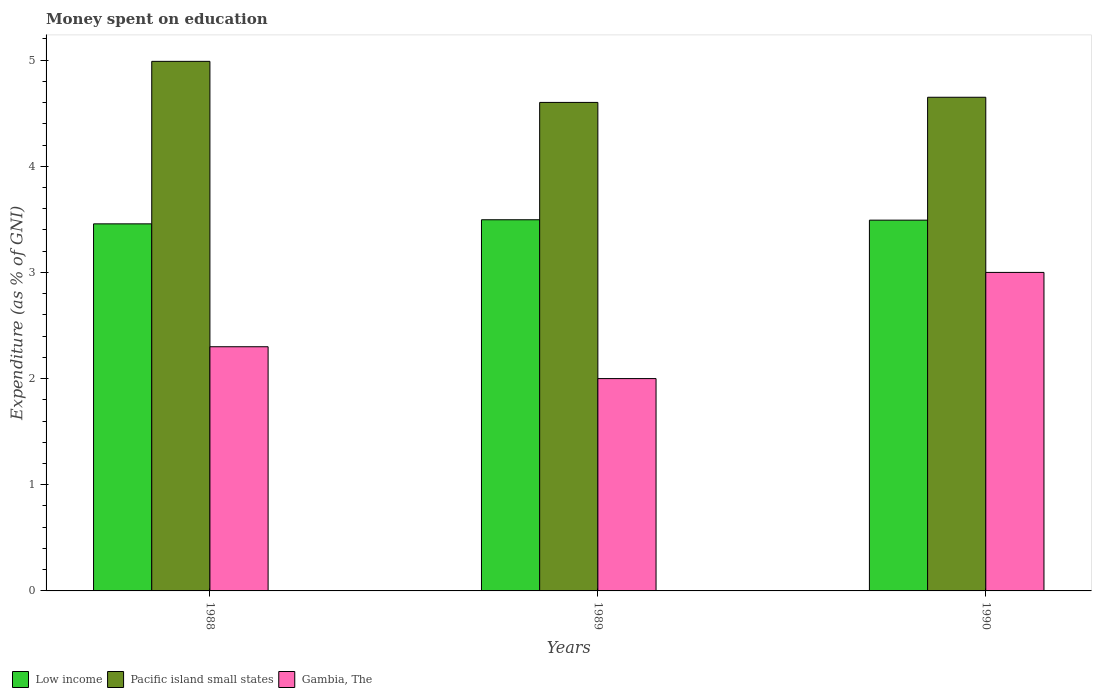How many different coloured bars are there?
Ensure brevity in your answer.  3. How many groups of bars are there?
Make the answer very short. 3. Are the number of bars per tick equal to the number of legend labels?
Provide a short and direct response. Yes. Are the number of bars on each tick of the X-axis equal?
Offer a terse response. Yes. How many bars are there on the 3rd tick from the right?
Provide a succinct answer. 3. What is the label of the 2nd group of bars from the left?
Give a very brief answer. 1989. In how many cases, is the number of bars for a given year not equal to the number of legend labels?
Keep it short and to the point. 0. What is the amount of money spent on education in Low income in 1989?
Your answer should be very brief. 3.5. Across all years, what is the maximum amount of money spent on education in Low income?
Your answer should be very brief. 3.5. Across all years, what is the minimum amount of money spent on education in Pacific island small states?
Ensure brevity in your answer.  4.6. In which year was the amount of money spent on education in Low income minimum?
Offer a very short reply. 1988. What is the total amount of money spent on education in Gambia, The in the graph?
Give a very brief answer. 7.3. What is the difference between the amount of money spent on education in Pacific island small states in 1988 and that in 1990?
Ensure brevity in your answer.  0.34. What is the difference between the amount of money spent on education in Low income in 1988 and the amount of money spent on education in Pacific island small states in 1990?
Offer a terse response. -1.19. What is the average amount of money spent on education in Low income per year?
Keep it short and to the point. 3.48. In the year 1988, what is the difference between the amount of money spent on education in Low income and amount of money spent on education in Gambia, The?
Offer a terse response. 1.16. In how many years, is the amount of money spent on education in Gambia, The greater than 0.4 %?
Your response must be concise. 3. What is the ratio of the amount of money spent on education in Gambia, The in 1988 to that in 1989?
Provide a short and direct response. 1.15. What is the difference between the highest and the second highest amount of money spent on education in Gambia, The?
Offer a terse response. 0.7. What is the difference between the highest and the lowest amount of money spent on education in Low income?
Keep it short and to the point. 0.04. What does the 3rd bar from the left in 1988 represents?
Your answer should be compact. Gambia, The. What does the 2nd bar from the right in 1989 represents?
Your answer should be very brief. Pacific island small states. How many years are there in the graph?
Provide a succinct answer. 3. How many legend labels are there?
Provide a short and direct response. 3. How are the legend labels stacked?
Offer a very short reply. Horizontal. What is the title of the graph?
Provide a short and direct response. Money spent on education. What is the label or title of the Y-axis?
Your answer should be very brief. Expenditure (as % of GNI). What is the Expenditure (as % of GNI) of Low income in 1988?
Keep it short and to the point. 3.46. What is the Expenditure (as % of GNI) of Pacific island small states in 1988?
Offer a terse response. 4.99. What is the Expenditure (as % of GNI) in Gambia, The in 1988?
Provide a short and direct response. 2.3. What is the Expenditure (as % of GNI) in Low income in 1989?
Provide a succinct answer. 3.5. What is the Expenditure (as % of GNI) in Pacific island small states in 1989?
Provide a succinct answer. 4.6. What is the Expenditure (as % of GNI) of Low income in 1990?
Make the answer very short. 3.49. What is the Expenditure (as % of GNI) in Pacific island small states in 1990?
Provide a short and direct response. 4.65. What is the Expenditure (as % of GNI) of Gambia, The in 1990?
Offer a very short reply. 3. Across all years, what is the maximum Expenditure (as % of GNI) in Low income?
Offer a very short reply. 3.5. Across all years, what is the maximum Expenditure (as % of GNI) in Pacific island small states?
Offer a very short reply. 4.99. Across all years, what is the maximum Expenditure (as % of GNI) in Gambia, The?
Offer a terse response. 3. Across all years, what is the minimum Expenditure (as % of GNI) of Low income?
Offer a terse response. 3.46. Across all years, what is the minimum Expenditure (as % of GNI) of Pacific island small states?
Offer a very short reply. 4.6. Across all years, what is the minimum Expenditure (as % of GNI) in Gambia, The?
Your response must be concise. 2. What is the total Expenditure (as % of GNI) of Low income in the graph?
Your answer should be compact. 10.45. What is the total Expenditure (as % of GNI) in Pacific island small states in the graph?
Ensure brevity in your answer.  14.24. What is the difference between the Expenditure (as % of GNI) of Low income in 1988 and that in 1989?
Provide a short and direct response. -0.04. What is the difference between the Expenditure (as % of GNI) of Pacific island small states in 1988 and that in 1989?
Give a very brief answer. 0.39. What is the difference between the Expenditure (as % of GNI) of Gambia, The in 1988 and that in 1989?
Provide a succinct answer. 0.3. What is the difference between the Expenditure (as % of GNI) in Low income in 1988 and that in 1990?
Ensure brevity in your answer.  -0.03. What is the difference between the Expenditure (as % of GNI) of Pacific island small states in 1988 and that in 1990?
Offer a very short reply. 0.34. What is the difference between the Expenditure (as % of GNI) of Gambia, The in 1988 and that in 1990?
Ensure brevity in your answer.  -0.7. What is the difference between the Expenditure (as % of GNI) of Low income in 1989 and that in 1990?
Make the answer very short. 0. What is the difference between the Expenditure (as % of GNI) in Pacific island small states in 1989 and that in 1990?
Keep it short and to the point. -0.05. What is the difference between the Expenditure (as % of GNI) in Gambia, The in 1989 and that in 1990?
Provide a succinct answer. -1. What is the difference between the Expenditure (as % of GNI) in Low income in 1988 and the Expenditure (as % of GNI) in Pacific island small states in 1989?
Give a very brief answer. -1.14. What is the difference between the Expenditure (as % of GNI) in Low income in 1988 and the Expenditure (as % of GNI) in Gambia, The in 1989?
Ensure brevity in your answer.  1.46. What is the difference between the Expenditure (as % of GNI) in Pacific island small states in 1988 and the Expenditure (as % of GNI) in Gambia, The in 1989?
Make the answer very short. 2.99. What is the difference between the Expenditure (as % of GNI) of Low income in 1988 and the Expenditure (as % of GNI) of Pacific island small states in 1990?
Keep it short and to the point. -1.19. What is the difference between the Expenditure (as % of GNI) in Low income in 1988 and the Expenditure (as % of GNI) in Gambia, The in 1990?
Provide a short and direct response. 0.46. What is the difference between the Expenditure (as % of GNI) of Pacific island small states in 1988 and the Expenditure (as % of GNI) of Gambia, The in 1990?
Your answer should be compact. 1.99. What is the difference between the Expenditure (as % of GNI) in Low income in 1989 and the Expenditure (as % of GNI) in Pacific island small states in 1990?
Offer a terse response. -1.15. What is the difference between the Expenditure (as % of GNI) of Low income in 1989 and the Expenditure (as % of GNI) of Gambia, The in 1990?
Offer a terse response. 0.5. What is the difference between the Expenditure (as % of GNI) in Pacific island small states in 1989 and the Expenditure (as % of GNI) in Gambia, The in 1990?
Your answer should be very brief. 1.6. What is the average Expenditure (as % of GNI) in Low income per year?
Offer a very short reply. 3.48. What is the average Expenditure (as % of GNI) of Pacific island small states per year?
Ensure brevity in your answer.  4.75. What is the average Expenditure (as % of GNI) of Gambia, The per year?
Ensure brevity in your answer.  2.43. In the year 1988, what is the difference between the Expenditure (as % of GNI) in Low income and Expenditure (as % of GNI) in Pacific island small states?
Your answer should be compact. -1.53. In the year 1988, what is the difference between the Expenditure (as % of GNI) of Low income and Expenditure (as % of GNI) of Gambia, The?
Provide a short and direct response. 1.16. In the year 1988, what is the difference between the Expenditure (as % of GNI) in Pacific island small states and Expenditure (as % of GNI) in Gambia, The?
Your response must be concise. 2.69. In the year 1989, what is the difference between the Expenditure (as % of GNI) in Low income and Expenditure (as % of GNI) in Pacific island small states?
Your answer should be compact. -1.11. In the year 1989, what is the difference between the Expenditure (as % of GNI) in Low income and Expenditure (as % of GNI) in Gambia, The?
Your answer should be very brief. 1.5. In the year 1989, what is the difference between the Expenditure (as % of GNI) of Pacific island small states and Expenditure (as % of GNI) of Gambia, The?
Your response must be concise. 2.6. In the year 1990, what is the difference between the Expenditure (as % of GNI) of Low income and Expenditure (as % of GNI) of Pacific island small states?
Provide a short and direct response. -1.16. In the year 1990, what is the difference between the Expenditure (as % of GNI) in Low income and Expenditure (as % of GNI) in Gambia, The?
Offer a very short reply. 0.49. In the year 1990, what is the difference between the Expenditure (as % of GNI) of Pacific island small states and Expenditure (as % of GNI) of Gambia, The?
Your response must be concise. 1.65. What is the ratio of the Expenditure (as % of GNI) in Pacific island small states in 1988 to that in 1989?
Provide a succinct answer. 1.08. What is the ratio of the Expenditure (as % of GNI) of Gambia, The in 1988 to that in 1989?
Give a very brief answer. 1.15. What is the ratio of the Expenditure (as % of GNI) of Low income in 1988 to that in 1990?
Provide a succinct answer. 0.99. What is the ratio of the Expenditure (as % of GNI) in Pacific island small states in 1988 to that in 1990?
Offer a very short reply. 1.07. What is the ratio of the Expenditure (as % of GNI) of Gambia, The in 1988 to that in 1990?
Give a very brief answer. 0.77. What is the ratio of the Expenditure (as % of GNI) of Gambia, The in 1989 to that in 1990?
Your response must be concise. 0.67. What is the difference between the highest and the second highest Expenditure (as % of GNI) in Low income?
Ensure brevity in your answer.  0. What is the difference between the highest and the second highest Expenditure (as % of GNI) of Pacific island small states?
Offer a very short reply. 0.34. What is the difference between the highest and the lowest Expenditure (as % of GNI) of Low income?
Your answer should be very brief. 0.04. What is the difference between the highest and the lowest Expenditure (as % of GNI) in Pacific island small states?
Provide a succinct answer. 0.39. 